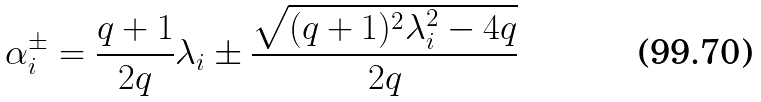<formula> <loc_0><loc_0><loc_500><loc_500>\alpha _ { i } ^ { \pm } = \frac { q + 1 } { 2 q } \lambda _ { i } \pm \frac { \sqrt { ( q + 1 ) ^ { 2 } \lambda _ { i } ^ { 2 } - 4 q } } { 2 q }</formula> 